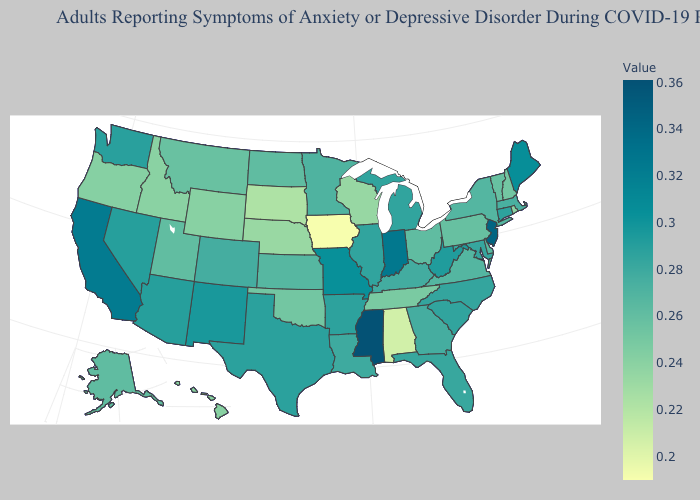Among the states that border New York , does Massachusetts have the lowest value?
Answer briefly. No. Among the states that border Indiana , does Illinois have the highest value?
Be succinct. Yes. Does Arkansas have a higher value than Montana?
Answer briefly. Yes. Does Rhode Island have a higher value than Iowa?
Answer briefly. Yes. Does Alabama have the lowest value in the South?
Keep it brief. Yes. Among the states that border Missouri , does Kansas have the lowest value?
Keep it brief. No. 